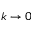<formula> <loc_0><loc_0><loc_500><loc_500>k \to 0</formula> 